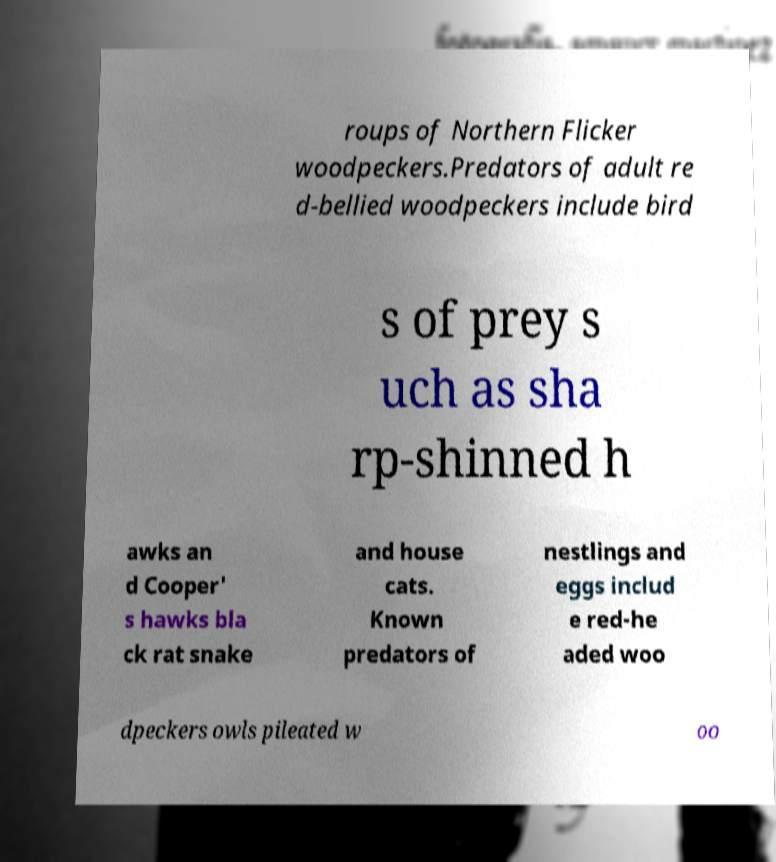What messages or text are displayed in this image? I need them in a readable, typed format. roups of Northern Flicker woodpeckers.Predators of adult re d-bellied woodpeckers include bird s of prey s uch as sha rp-shinned h awks an d Cooper' s hawks bla ck rat snake and house cats. Known predators of nestlings and eggs includ e red-he aded woo dpeckers owls pileated w oo 